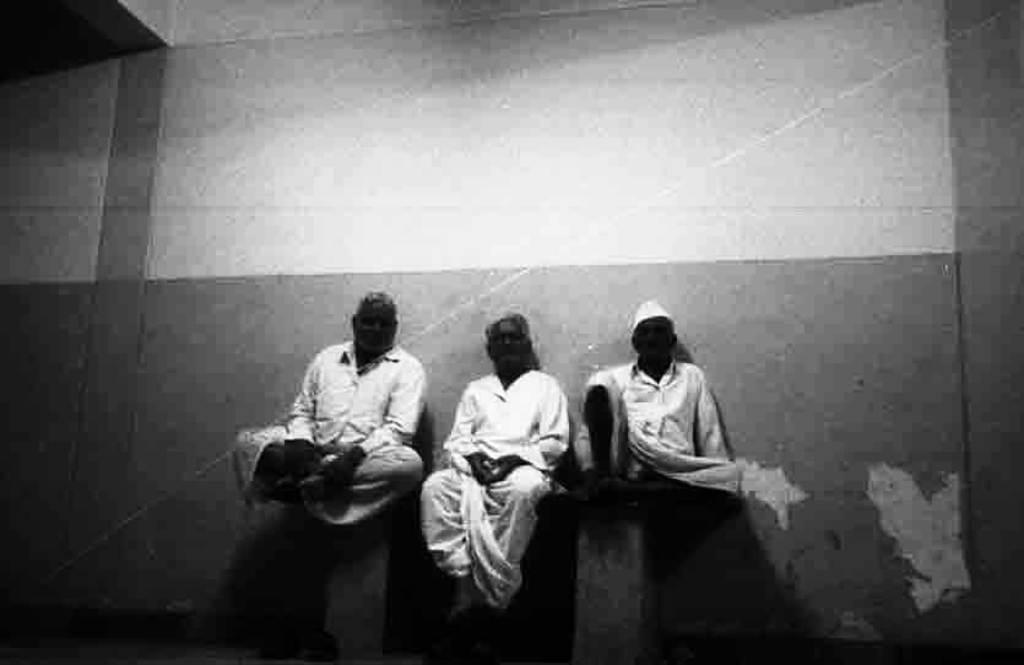How many people are in the image? There are three persons in the image. What are the persons wearing? The persons are wearing white dresses. What are the persons doing in the image? The persons are sitting. What can be seen behind the persons? There is a wall behind the persons. Where is the library located in the image? There is no library present in the image. Is there a water fountain visible in the image? There is no water fountain present in the image. 